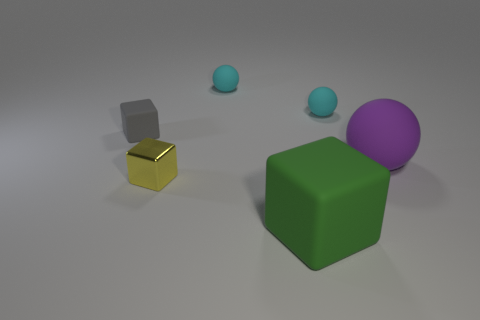Does the small object in front of the small matte block have the same shape as the green matte thing?
Your answer should be very brief. Yes. What number of purple objects have the same shape as the yellow metallic object?
Offer a very short reply. 0. Are there any small gray spheres made of the same material as the gray cube?
Your answer should be compact. No. The small cyan ball that is on the right side of the block that is right of the yellow metallic block is made of what material?
Your answer should be very brief. Rubber. There is a cyan rubber thing on the left side of the big green matte block; how big is it?
Your response must be concise. Small. Is the large green object made of the same material as the cube behind the big purple object?
Offer a very short reply. Yes. What number of tiny objects are cyan balls or gray matte blocks?
Give a very brief answer. 3. Is the number of large purple things less than the number of tiny green rubber balls?
Your answer should be very brief. No. There is a purple object on the right side of the big green rubber thing; is it the same size as the yellow thing in front of the tiny gray rubber thing?
Keep it short and to the point. No. What number of cyan things are either small cubes or cubes?
Offer a terse response. 0. 